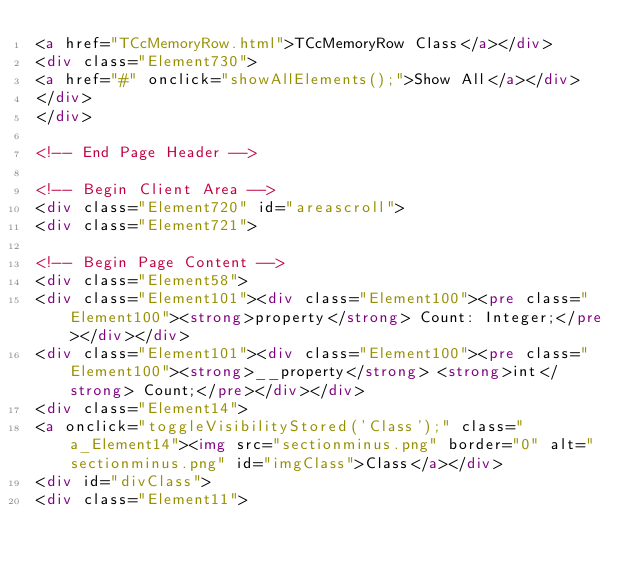Convert code to text. <code><loc_0><loc_0><loc_500><loc_500><_HTML_><a href="TCcMemoryRow.html">TCcMemoryRow Class</a></div>
<div class="Element730">
<a href="#" onclick="showAllElements();">Show All</a></div>
</div>
</div>

<!-- End Page Header -->

<!-- Begin Client Area -->
<div class="Element720" id="areascroll">
<div class="Element721">

<!-- Begin Page Content -->
<div class="Element58">
<div class="Element101"><div class="Element100"><pre class="Element100"><strong>property</strong> Count: Integer;</pre></div></div>
<div class="Element101"><div class="Element100"><pre class="Element100"><strong>__property</strong> <strong>int</strong> Count;</pre></div></div>
<div class="Element14">
<a onclick="toggleVisibilityStored('Class');" class="a_Element14"><img src="sectionminus.png" border="0" alt="sectionminus.png" id="imgClass">Class</a></div>
<div id="divClass">
<div class="Element11"></code> 